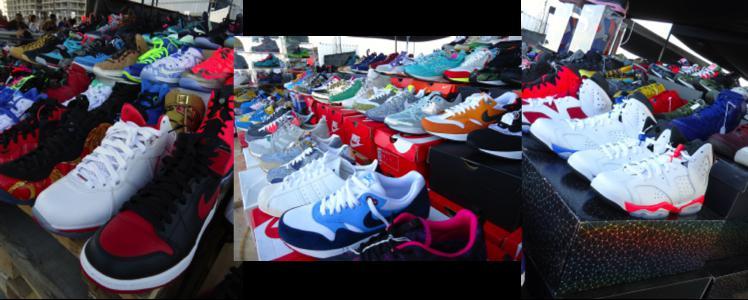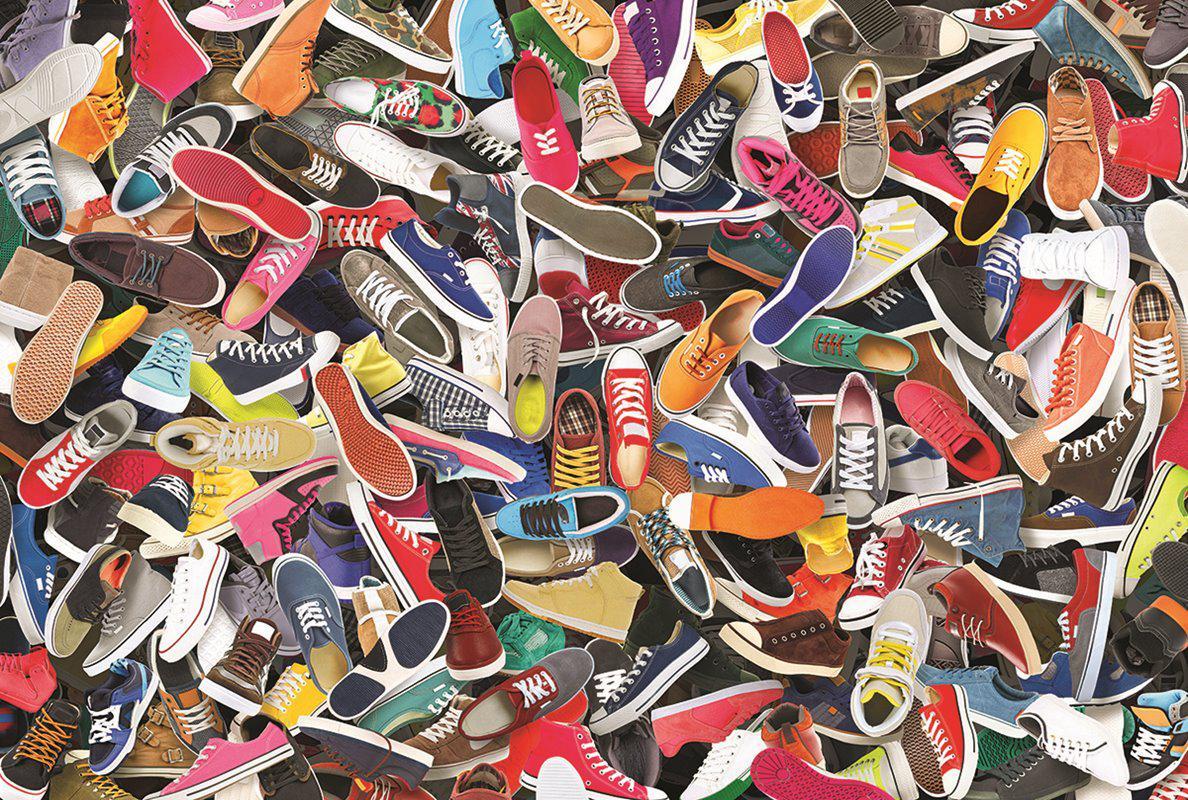The first image is the image on the left, the second image is the image on the right. Given the left and right images, does the statement "At least one image has shoes that are not stacked in a random pile" hold true? Answer yes or no. Yes. The first image is the image on the left, the second image is the image on the right. For the images shown, is this caption "An image shows shoes lined up in rows in store displays." true? Answer yes or no. Yes. 